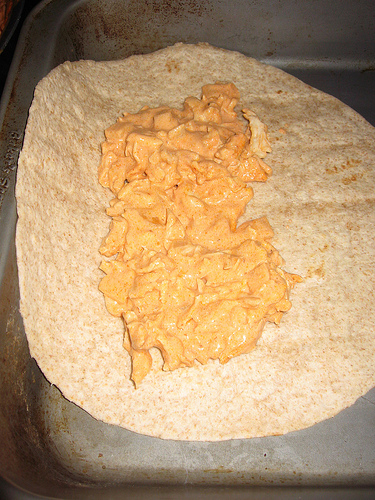<image>
Is there a pan under the food? Yes. The pan is positioned underneath the food, with the food above it in the vertical space. 